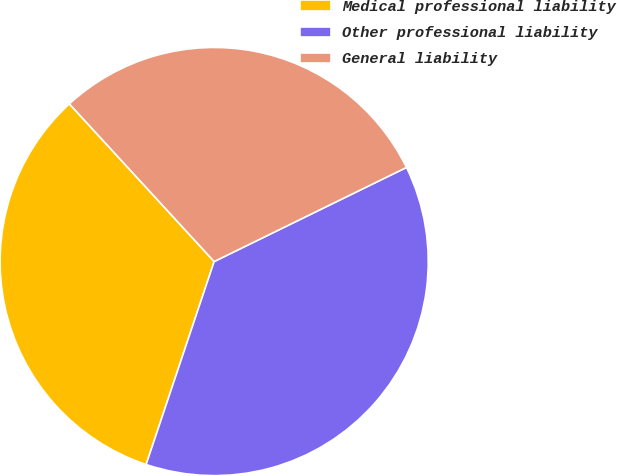Convert chart to OTSL. <chart><loc_0><loc_0><loc_500><loc_500><pie_chart><fcel>Medical professional liability<fcel>Other professional liability<fcel>General liability<nl><fcel>33.03%<fcel>37.39%<fcel>29.58%<nl></chart> 